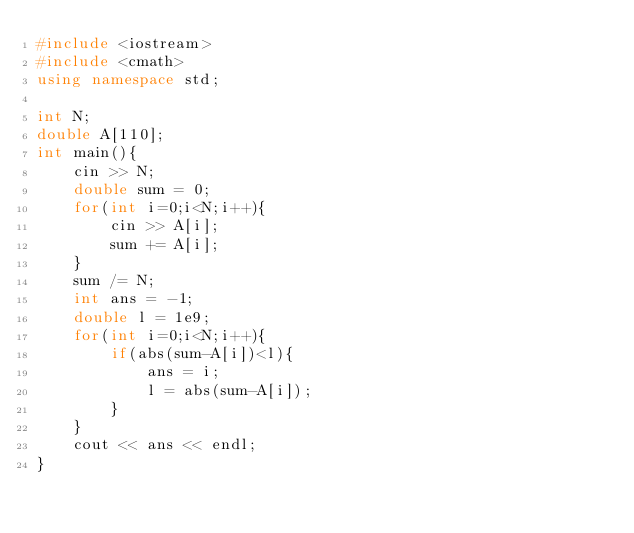<code> <loc_0><loc_0><loc_500><loc_500><_C++_>#include <iostream>
#include <cmath>
using namespace std;

int N;
double A[110];
int main(){
	cin >> N;
	double sum = 0;
	for(int i=0;i<N;i++){
		cin >> A[i];
		sum += A[i];
	}
	sum /= N;
	int ans = -1;
	double l = 1e9;
	for(int i=0;i<N;i++){
		if(abs(sum-A[i])<l){
			ans = i;
			l = abs(sum-A[i]);
		}
	}
	cout << ans << endl;
}</code> 